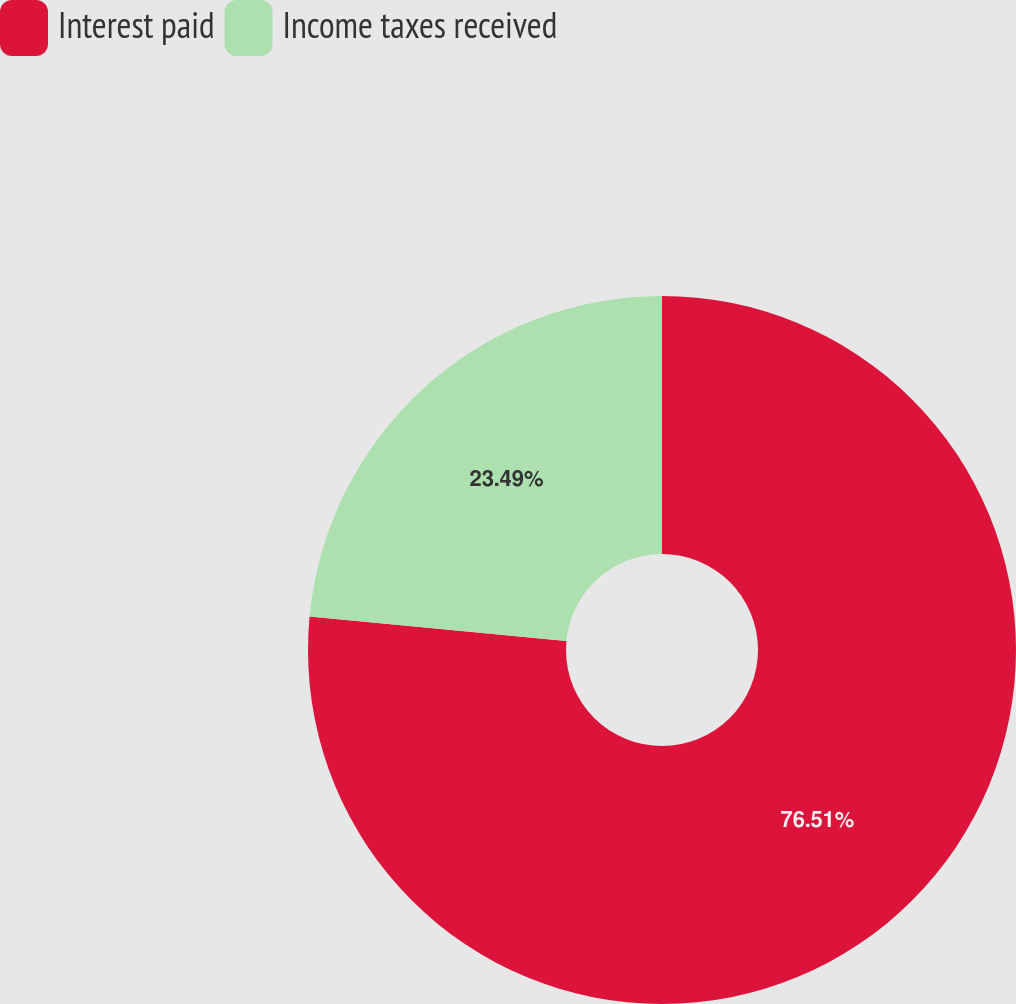Convert chart to OTSL. <chart><loc_0><loc_0><loc_500><loc_500><pie_chart><fcel>Interest paid<fcel>Income taxes received<nl><fcel>76.51%<fcel>23.49%<nl></chart> 